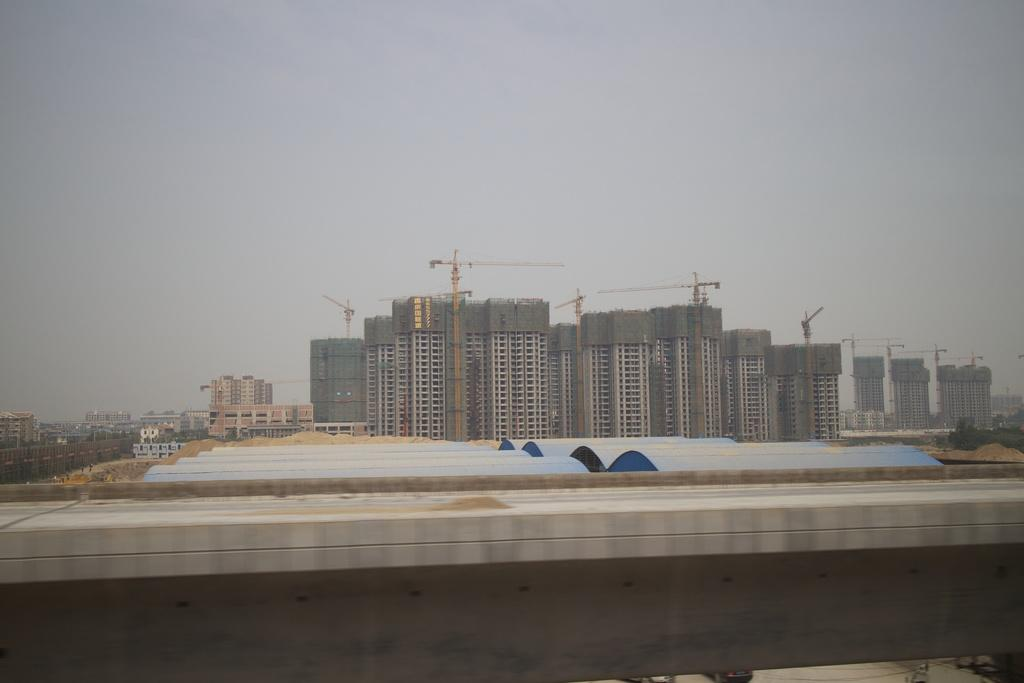What type of structures are being built in the image? There are buildings under construction in the image. Can you describe the other structures visible in the image? There are other buildings in the left corner of the image. What type of yarn is being used to weave the buildings in the image? There is no yarn present in the image, and the buildings are not being woven. 